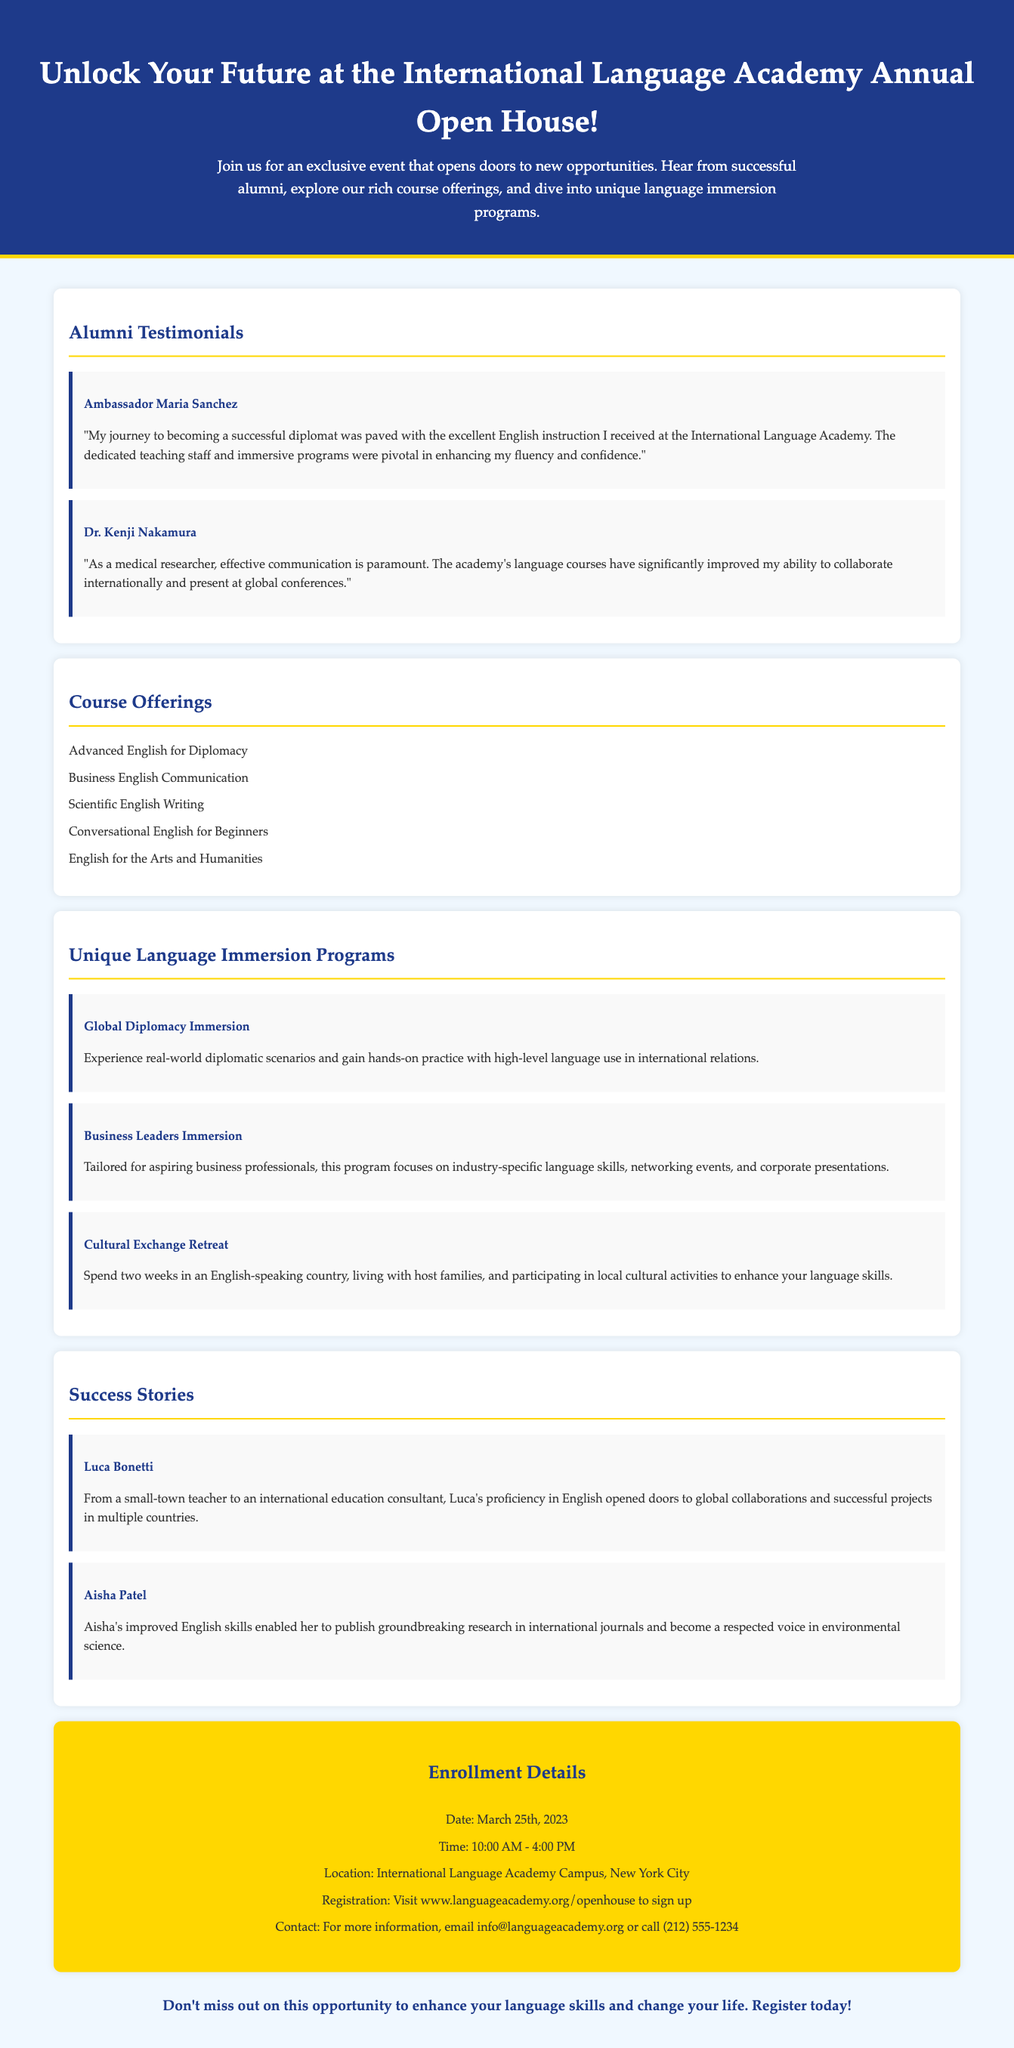What is the date of the Open House? The Open House is scheduled for March 25th, 2023, as mentioned in the enrollment details section.
Answer: March 25th, 2023 Who is the testimonial from that talks about becoming a successful diplomat? The testimonial is from Ambassador Maria Sanchez, who values the English instruction received at the academy for her career.
Answer: Ambassador Maria Sanchez What is one of the course offerings listed in the document? The document lists several course offerings, including Advanced English for Diplomacy as one of them.
Answer: Advanced English for Diplomacy What is the location of the International Language Academy? The document states that the academy is located in New York City, specifically during the enrollment details section.
Answer: New York City Which immersion program focuses on industry-specific language skills? The Business Leaders Immersion program is tailored for aspiring business professionals focusing on industry-specific language skills.
Answer: Business Leaders Immersion How many hours does the Open House event last? The event runs from 10:00 AM to 4:00 PM, which totals 6 hours.
Answer: 6 hours Who is mentioned as having become an international education consultant? Luca Bonetti is the success story mentioned who transitioned from a small-town teacher to an international education consultant.
Answer: Luca Bonetti What program allows spending two weeks in an English-speaking country? The Cultural Exchange Retreat program offers the opportunity to spend two weeks in an English-speaking country with host families.
Answer: Cultural Exchange Retreat 